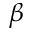Convert formula to latex. <formula><loc_0><loc_0><loc_500><loc_500>\beta</formula> 